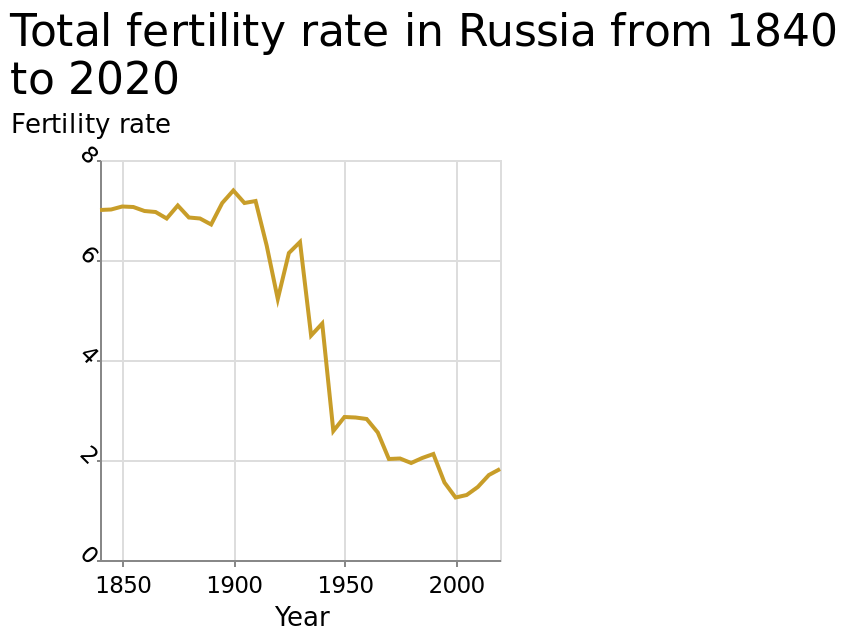<image>
When were fertility rates at their lowest?  Fertility rates were at their lowest from the 2000s. What happened to fertility rates between 1900 and 2020?  Fertility rates dropped substantially between 1900 and 2020. Offer a thorough analysis of the image. Fertility rates dropped substantially between1900 to 2020. Fertility rates were at the highest before the 1900s. Fertility rates were at the lowest from the 2000s. When were fertility rates at their highest?  Fertility rates were at their highest before the 1900s. 